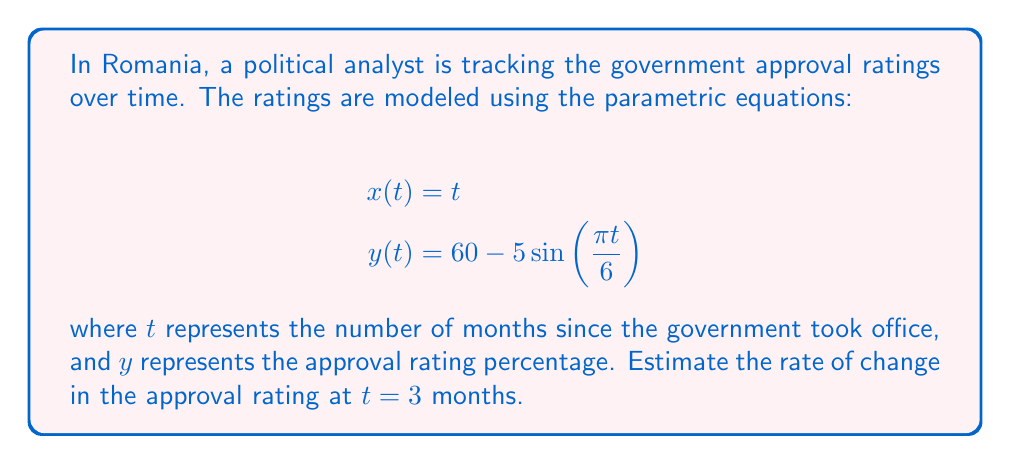Could you help me with this problem? To estimate the rate of change in the approval rating at $t = 3$ months, we need to calculate $\frac{dy}{dx}$ at that point. Since we have parametric equations, we'll use the chain rule:

$$\frac{dy}{dx} = \frac{dy/dt}{dx/dt}$$

1. First, let's find $\frac{dx}{dt}$:
   $$\frac{dx}{dt} = 1$$

2. Next, let's find $\frac{dy}{dt}$:
   $$\frac{dy}{dt} = -5 \cdot \frac{\pi}{6} \cos(\frac{\pi t}{6})$$

3. Now we can substitute these into our equation for $\frac{dy}{dx}$:
   $$\frac{dy}{dx} = \frac{-5 \cdot \frac{\pi}{6} \cos(\frac{\pi t}{6})}{1} = -\frac{5\pi}{6} \cos(\frac{\pi t}{6})$$

4. To find the rate of change at $t = 3$, we substitute $t = 3$ into this equation:
   $$\frac{dy}{dx}|_{t=3} = -\frac{5\pi}{6} \cos(\frac{\pi \cdot 3}{6}) = -\frac{5\pi}{6} \cos(\frac{\pi}{2}) = 0$$

Therefore, the rate of change in the approval rating at $t = 3$ months is 0 percentage points per month.
Answer: The rate of change in the government approval rating at $t = 3$ months is 0 percentage points per month. 